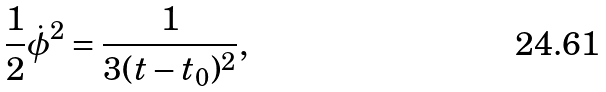<formula> <loc_0><loc_0><loc_500><loc_500>{ \frac { 1 } { 2 } \dot { \phi } ^ { 2 } = \frac { 1 } { 3 ( t - t _ { 0 } ) ^ { 2 } } , }</formula> 